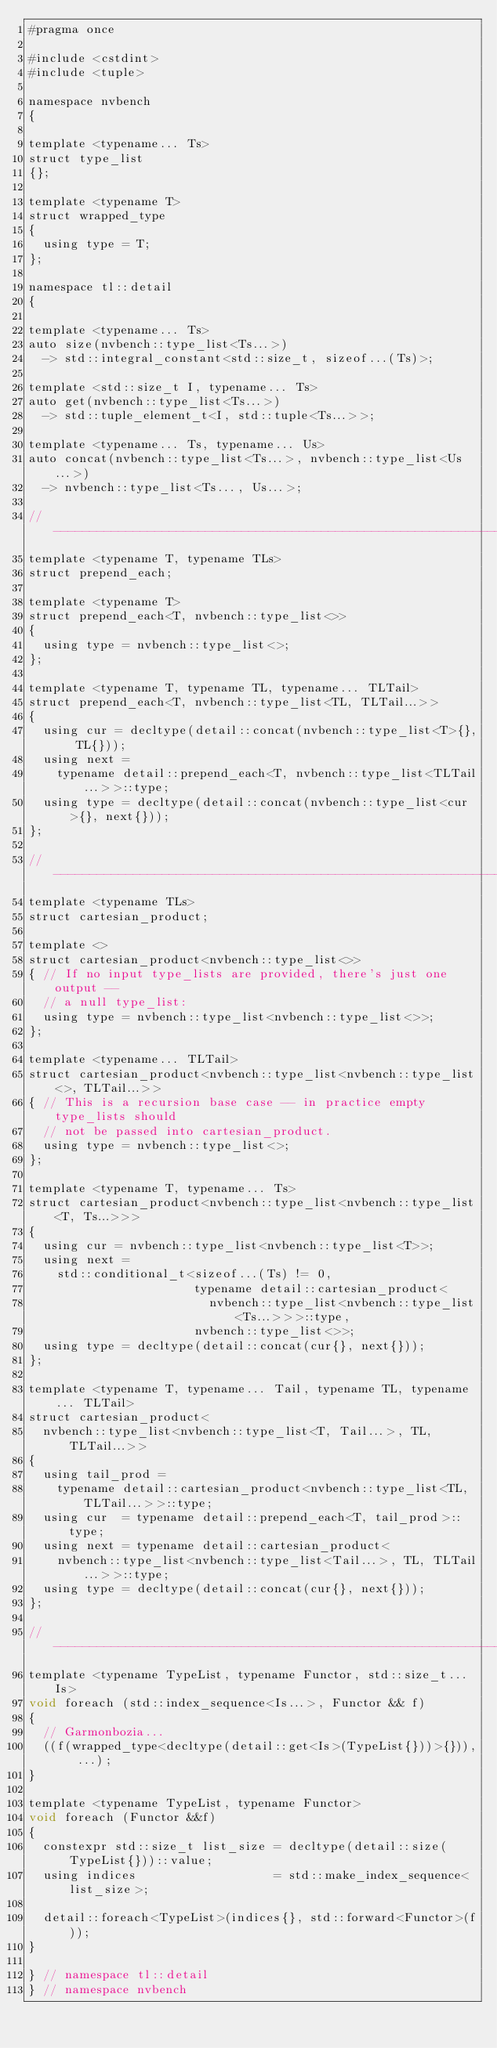<code> <loc_0><loc_0><loc_500><loc_500><_Cuda_>#pragma once

#include <cstdint>
#include <tuple>

namespace nvbench
{

template <typename... Ts>
struct type_list
{};

template <typename T>
struct wrapped_type
{
  using type = T;
};

namespace tl::detail
{

template <typename... Ts>
auto size(nvbench::type_list<Ts...>)
  -> std::integral_constant<std::size_t, sizeof...(Ts)>;

template <std::size_t I, typename... Ts>
auto get(nvbench::type_list<Ts...>)
  -> std::tuple_element_t<I, std::tuple<Ts...>>;

template <typename... Ts, typename... Us>
auto concat(nvbench::type_list<Ts...>, nvbench::type_list<Us...>)
  -> nvbench::type_list<Ts..., Us...>;

//------------------------------------------------------------------------------
template <typename T, typename TLs>
struct prepend_each;

template <typename T>
struct prepend_each<T, nvbench::type_list<>>
{
  using type = nvbench::type_list<>;
};

template <typename T, typename TL, typename... TLTail>
struct prepend_each<T, nvbench::type_list<TL, TLTail...>>
{
  using cur = decltype(detail::concat(nvbench::type_list<T>{}, TL{}));
  using next =
    typename detail::prepend_each<T, nvbench::type_list<TLTail...>>::type;
  using type = decltype(detail::concat(nvbench::type_list<cur>{}, next{}));
};

//------------------------------------------------------------------------------
template <typename TLs>
struct cartesian_product;

template <>
struct cartesian_product<nvbench::type_list<>>
{ // If no input type_lists are provided, there's just one output --
  // a null type_list:
  using type = nvbench::type_list<nvbench::type_list<>>;
};

template <typename... TLTail>
struct cartesian_product<nvbench::type_list<nvbench::type_list<>, TLTail...>>
{ // This is a recursion base case -- in practice empty type_lists should
  // not be passed into cartesian_product.
  using type = nvbench::type_list<>;
};

template <typename T, typename... Ts>
struct cartesian_product<nvbench::type_list<nvbench::type_list<T, Ts...>>>
{
  using cur = nvbench::type_list<nvbench::type_list<T>>;
  using next =
    std::conditional_t<sizeof...(Ts) != 0,
                       typename detail::cartesian_product<
                         nvbench::type_list<nvbench::type_list<Ts...>>>::type,
                       nvbench::type_list<>>;
  using type = decltype(detail::concat(cur{}, next{}));
};

template <typename T, typename... Tail, typename TL, typename... TLTail>
struct cartesian_product<
  nvbench::type_list<nvbench::type_list<T, Tail...>, TL, TLTail...>>
{
  using tail_prod =
    typename detail::cartesian_product<nvbench::type_list<TL, TLTail...>>::type;
  using cur  = typename detail::prepend_each<T, tail_prod>::type;
  using next = typename detail::cartesian_product<
    nvbench::type_list<nvbench::type_list<Tail...>, TL, TLTail...>>::type;
  using type = decltype(detail::concat(cur{}, next{}));
};

//------------------------------------------------------------------------------
template <typename TypeList, typename Functor, std::size_t... Is>
void foreach (std::index_sequence<Is...>, Functor && f)
{
  // Garmonbozia...
  ((f(wrapped_type<decltype(detail::get<Is>(TypeList{}))>{})), ...);
}

template <typename TypeList, typename Functor>
void foreach (Functor &&f)
{
  constexpr std::size_t list_size = decltype(detail::size(TypeList{}))::value;
  using indices                   = std::make_index_sequence<list_size>;

  detail::foreach<TypeList>(indices{}, std::forward<Functor>(f));
}

} // namespace tl::detail
} // namespace nvbench
</code> 